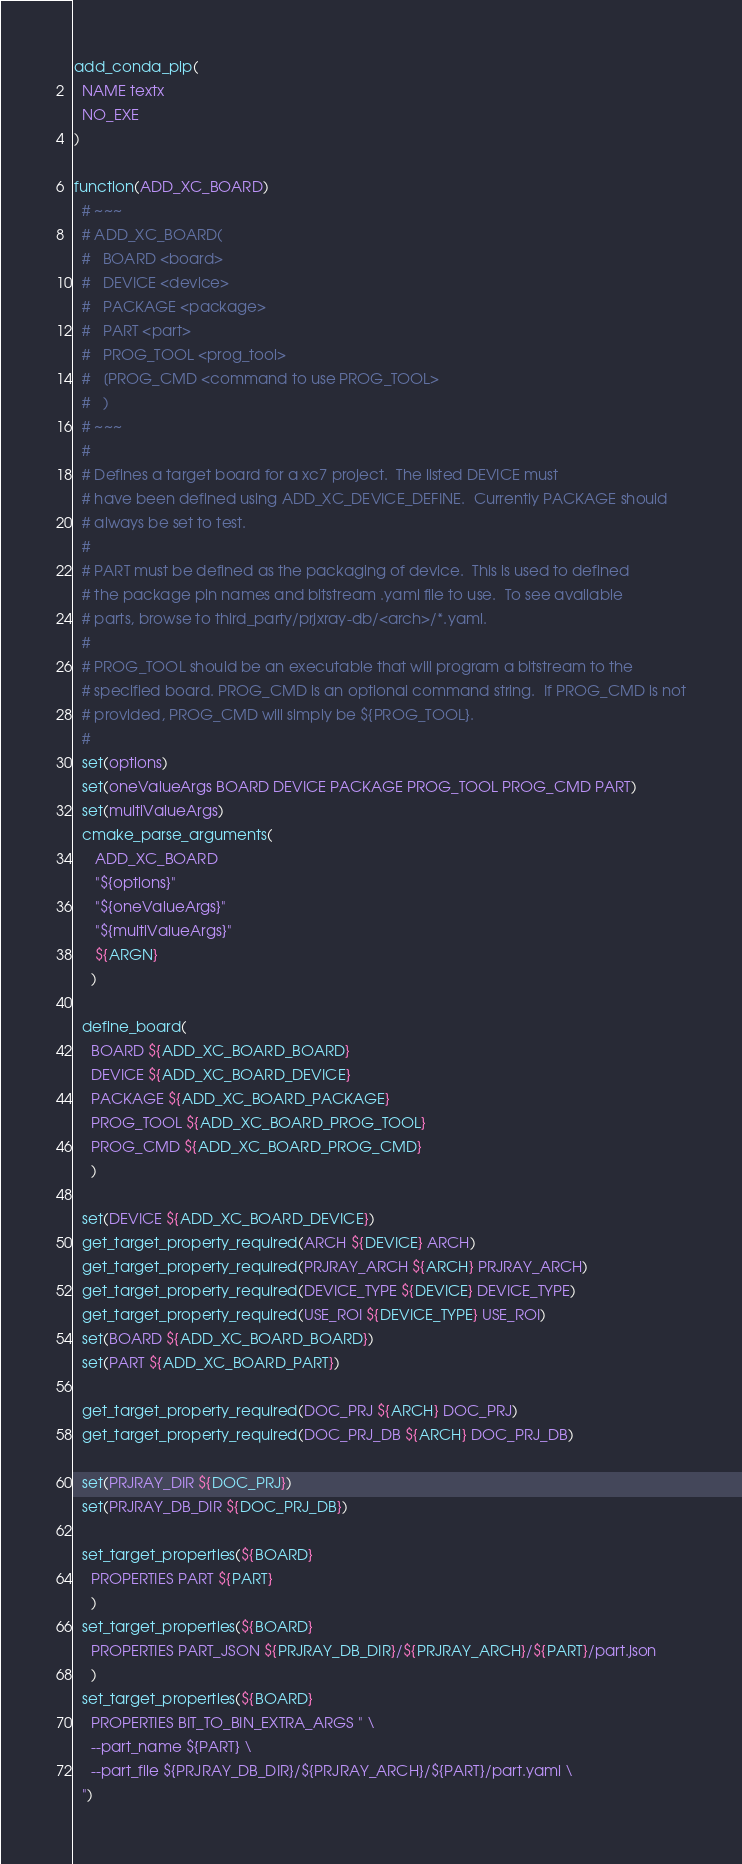<code> <loc_0><loc_0><loc_500><loc_500><_CMake_>add_conda_pip(
  NAME textx
  NO_EXE
)

function(ADD_XC_BOARD)
  # ~~~
  # ADD_XC_BOARD(
  #   BOARD <board>
  #   DEVICE <device>
  #   PACKAGE <package>
  #   PART <part>
  #   PROG_TOOL <prog_tool>
  #   [PROG_CMD <command to use PROG_TOOL>
  #   )
  # ~~~
  #
  # Defines a target board for a xc7 project.  The listed DEVICE must
  # have been defined using ADD_XC_DEVICE_DEFINE.  Currently PACKAGE should
  # always be set to test.
  #
  # PART must be defined as the packaging of device.  This is used to defined
  # the package pin names and bitstream .yaml file to use.  To see available
  # parts, browse to third_party/prjxray-db/<arch>/*.yaml.
  #
  # PROG_TOOL should be an executable that will program a bitstream to the
  # specified board. PROG_CMD is an optional command string.  If PROG_CMD is not
  # provided, PROG_CMD will simply be ${PROG_TOOL}.
  #
  set(options)
  set(oneValueArgs BOARD DEVICE PACKAGE PROG_TOOL PROG_CMD PART)
  set(multiValueArgs)
  cmake_parse_arguments(
     ADD_XC_BOARD
     "${options}"
     "${oneValueArgs}"
     "${multiValueArgs}"
     ${ARGN}
    )

  define_board(
    BOARD ${ADD_XC_BOARD_BOARD}
    DEVICE ${ADD_XC_BOARD_DEVICE}
    PACKAGE ${ADD_XC_BOARD_PACKAGE}
    PROG_TOOL ${ADD_XC_BOARD_PROG_TOOL}
    PROG_CMD ${ADD_XC_BOARD_PROG_CMD}
    )

  set(DEVICE ${ADD_XC_BOARD_DEVICE})
  get_target_property_required(ARCH ${DEVICE} ARCH)
  get_target_property_required(PRJRAY_ARCH ${ARCH} PRJRAY_ARCH)
  get_target_property_required(DEVICE_TYPE ${DEVICE} DEVICE_TYPE)
  get_target_property_required(USE_ROI ${DEVICE_TYPE} USE_ROI)
  set(BOARD ${ADD_XC_BOARD_BOARD})
  set(PART ${ADD_XC_BOARD_PART})

  get_target_property_required(DOC_PRJ ${ARCH} DOC_PRJ)
  get_target_property_required(DOC_PRJ_DB ${ARCH} DOC_PRJ_DB)

  set(PRJRAY_DIR ${DOC_PRJ})
  set(PRJRAY_DB_DIR ${DOC_PRJ_DB})

  set_target_properties(${BOARD}
    PROPERTIES PART ${PART}
    )
  set_target_properties(${BOARD}
    PROPERTIES PART_JSON ${PRJRAY_DB_DIR}/${PRJRAY_ARCH}/${PART}/part.json
    )
  set_target_properties(${BOARD}
    PROPERTIES BIT_TO_BIN_EXTRA_ARGS " \
    --part_name ${PART} \
    --part_file ${PRJRAY_DB_DIR}/${PRJRAY_ARCH}/${PART}/part.yaml \
  ")</code> 